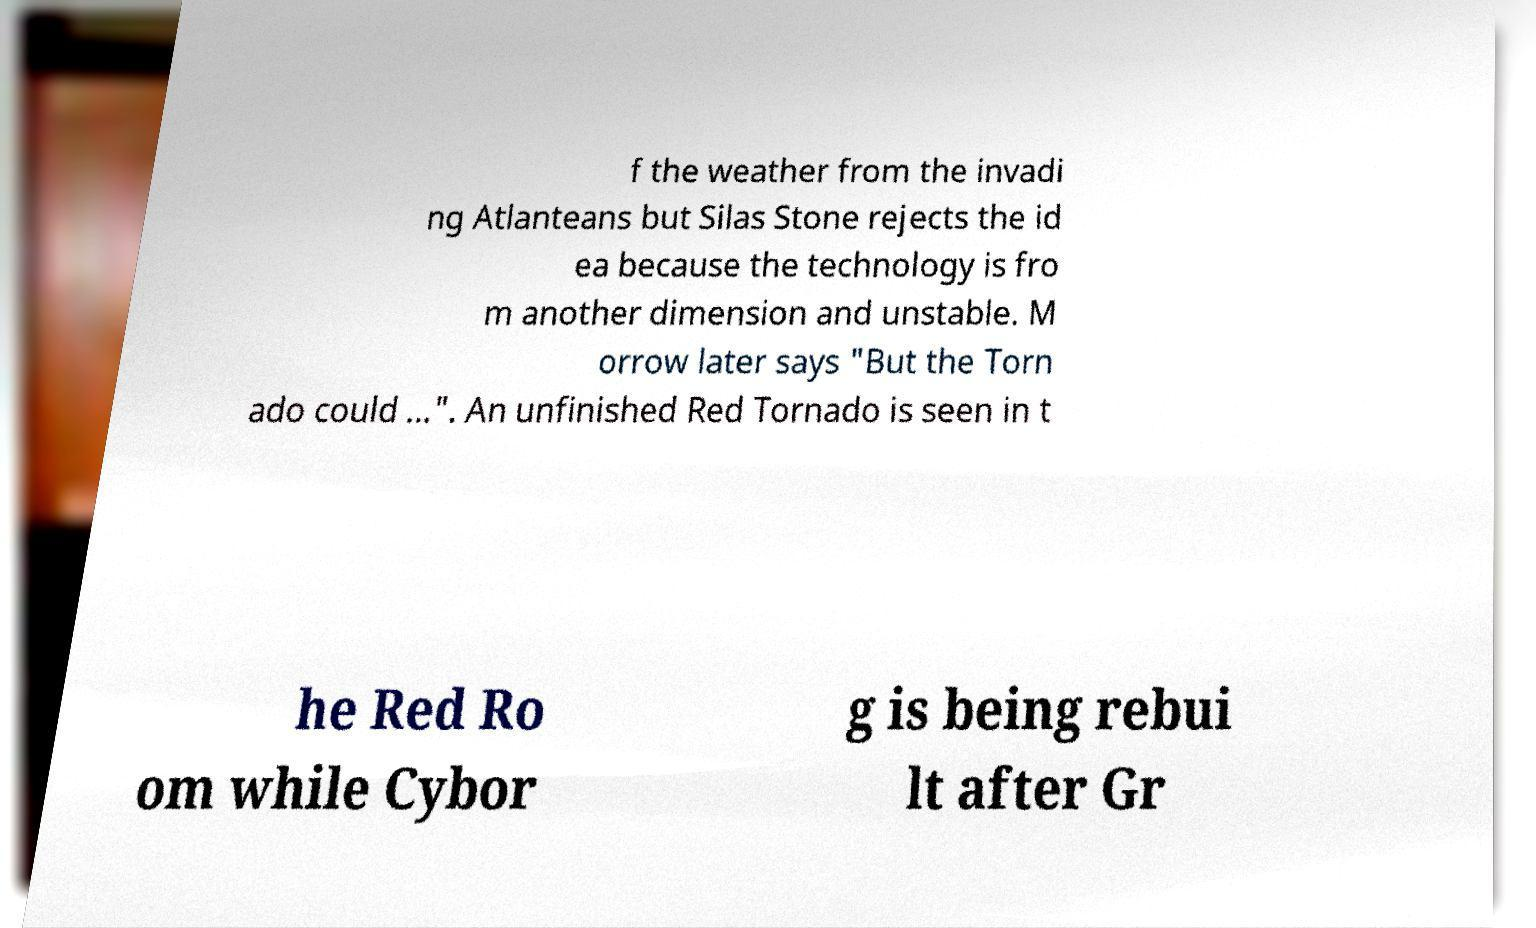Please identify and transcribe the text found in this image. f the weather from the invadi ng Atlanteans but Silas Stone rejects the id ea because the technology is fro m another dimension and unstable. M orrow later says "But the Torn ado could ...". An unfinished Red Tornado is seen in t he Red Ro om while Cybor g is being rebui lt after Gr 